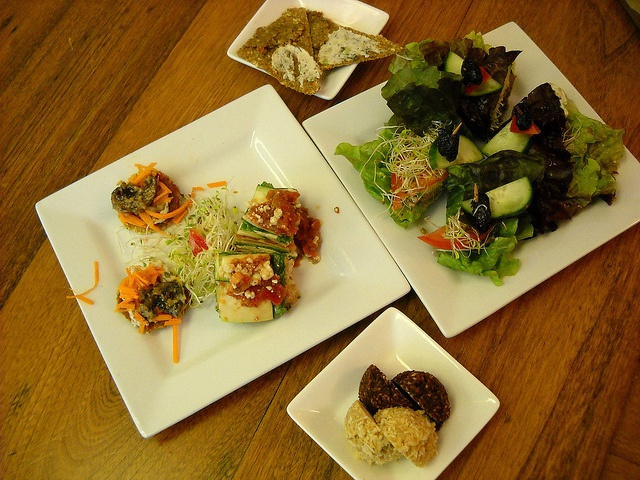Describe the objects in this image and their specific colors. I can see pizza in maroon, olive, and tan tones, carrot in maroon, olive, orange, khaki, and tan tones, carrot in maroon, orange, and red tones, carrot in maroon, orange, and olive tones, and carrot in maroon, red, brown, olive, and tan tones in this image. 